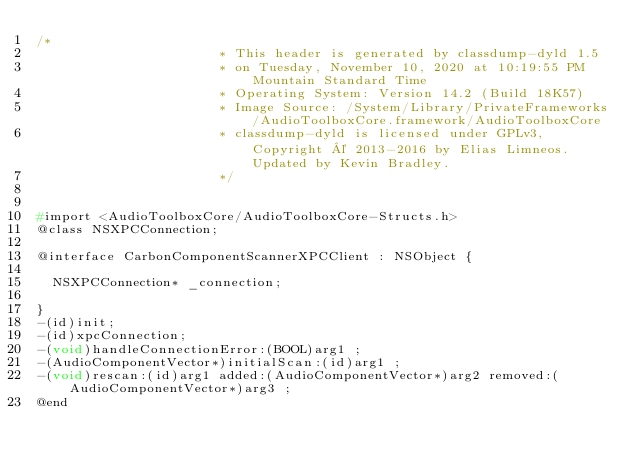<code> <loc_0><loc_0><loc_500><loc_500><_C_>/*
                       * This header is generated by classdump-dyld 1.5
                       * on Tuesday, November 10, 2020 at 10:19:55 PM Mountain Standard Time
                       * Operating System: Version 14.2 (Build 18K57)
                       * Image Source: /System/Library/PrivateFrameworks/AudioToolboxCore.framework/AudioToolboxCore
                       * classdump-dyld is licensed under GPLv3, Copyright © 2013-2016 by Elias Limneos. Updated by Kevin Bradley.
                       */


#import <AudioToolboxCore/AudioToolboxCore-Structs.h>
@class NSXPCConnection;

@interface CarbonComponentScannerXPCClient : NSObject {

	NSXPCConnection* _connection;

}
-(id)init;
-(id)xpcConnection;
-(void)handleConnectionError:(BOOL)arg1 ;
-(AudioComponentVector*)initialScan:(id)arg1 ;
-(void)rescan:(id)arg1 added:(AudioComponentVector*)arg2 removed:(AudioComponentVector*)arg3 ;
@end

</code> 